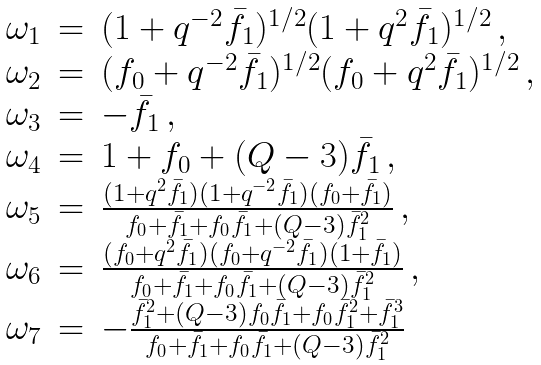<formula> <loc_0><loc_0><loc_500><loc_500>\begin{array} { l l l } \omega _ { 1 } & = & ( 1 + q ^ { - 2 } \bar { f } _ { 1 } ) ^ { 1 / 2 } ( 1 + q ^ { 2 } \bar { f } _ { 1 } ) ^ { 1 / 2 } \, , \\ \omega _ { 2 } & = & ( f _ { 0 } + q ^ { - 2 } \bar { f } _ { 1 } ) ^ { 1 / 2 } ( f _ { 0 } + q ^ { 2 } \bar { f } _ { 1 } ) ^ { 1 / 2 } \, , \\ \omega _ { 3 } & = & - \bar { f } _ { 1 } \, , \\ \omega _ { 4 } & = & 1 + f _ { 0 } + ( Q - 3 ) \bar { f } _ { 1 } \, , \\ \omega _ { 5 } & = & \frac { ( 1 + q ^ { 2 } \bar { f } _ { 1 } ) ( 1 + q ^ { - 2 } \bar { f } _ { 1 } ) ( f _ { 0 } + \bar { f } _ { 1 } ) } { f _ { 0 } + \bar { f } _ { 1 } + f _ { 0 } \bar { f } _ { 1 } + ( Q - 3 ) \bar { f } _ { 1 } ^ { 2 } } \, , \\ \omega _ { 6 } & = & \frac { ( f _ { 0 } + q ^ { 2 } \bar { f } _ { 1 } ) ( f _ { 0 } + q ^ { - 2 } \bar { f } _ { 1 } ) ( 1 + \bar { f } _ { 1 } ) } { f _ { 0 } + \bar { f } _ { 1 } + f _ { 0 } \bar { f } _ { 1 } + ( Q - 3 ) \bar { f } _ { 1 } ^ { 2 } } \, , \\ \omega _ { 7 } & = & - \frac { \bar { f } _ { 1 } ^ { 2 } + ( Q - 3 ) f _ { 0 } \bar { f } _ { 1 } + f _ { 0 } \bar { f } _ { 1 } ^ { 2 } + \bar { f } _ { 1 } ^ { 3 } } { f _ { 0 } + \bar { f } _ { 1 } + f _ { 0 } \bar { f } _ { 1 } + ( Q - 3 ) \bar { f } _ { 1 } ^ { 2 } } \end{array}</formula> 